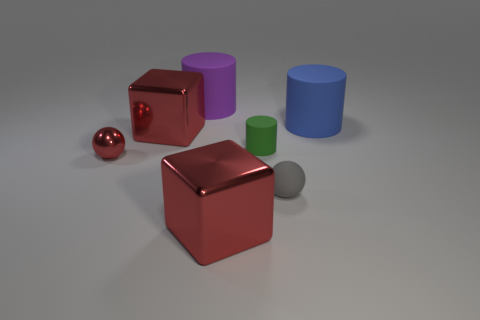Add 2 blue cylinders. How many objects exist? 9 Subtract all spheres. How many objects are left? 5 Subtract all tiny gray objects. Subtract all gray matte spheres. How many objects are left? 5 Add 7 purple rubber objects. How many purple rubber objects are left? 8 Add 5 purple objects. How many purple objects exist? 6 Subtract 1 purple cylinders. How many objects are left? 6 